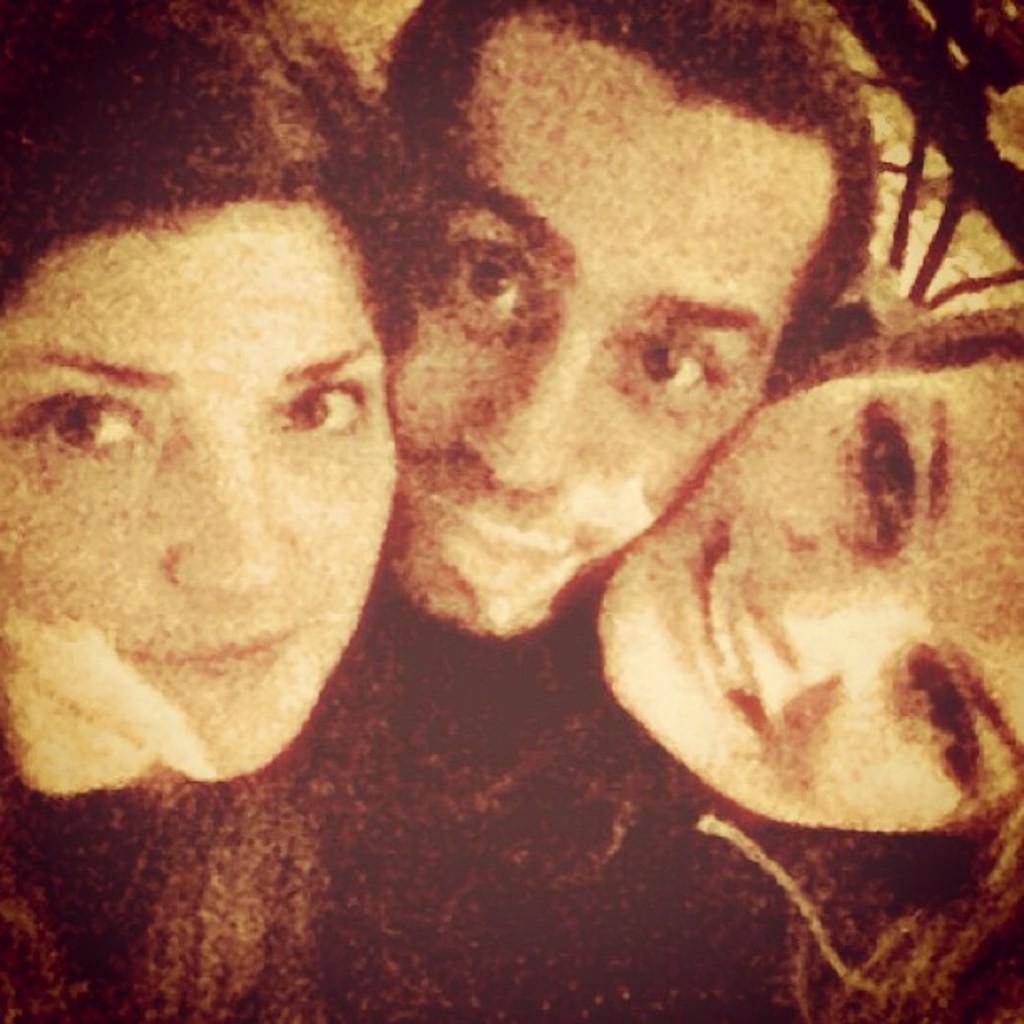Describe this image in one or two sentences. In this image I can see three people. To the side I can see the railing. And this is a edited image. 